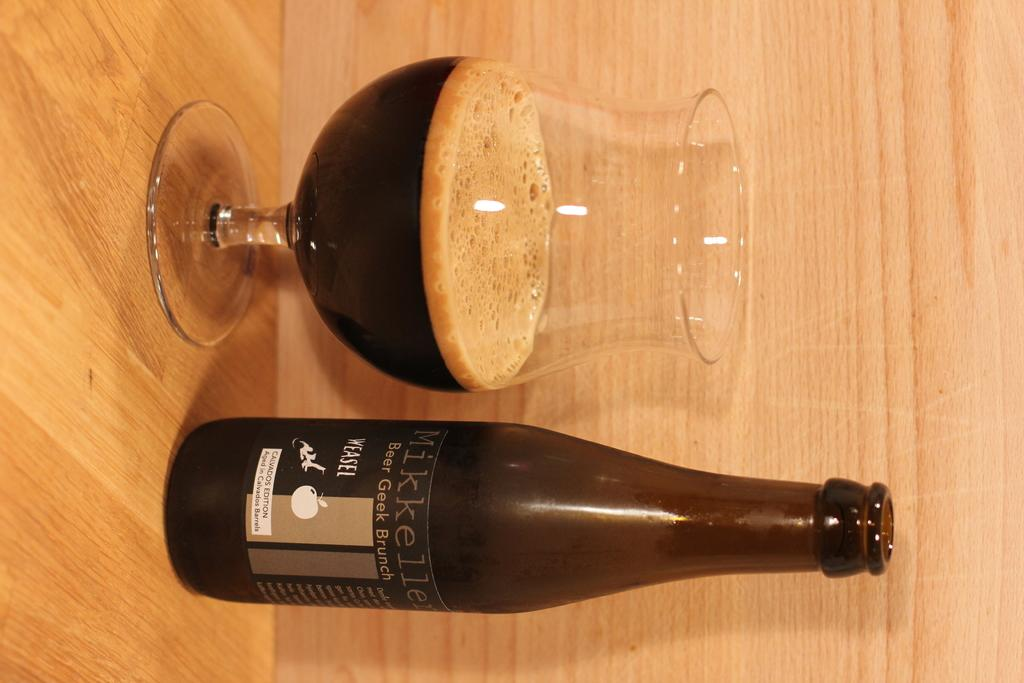<image>
Share a concise interpretation of the image provided. A bottle of Mikkeller sits next to a half full glass. 